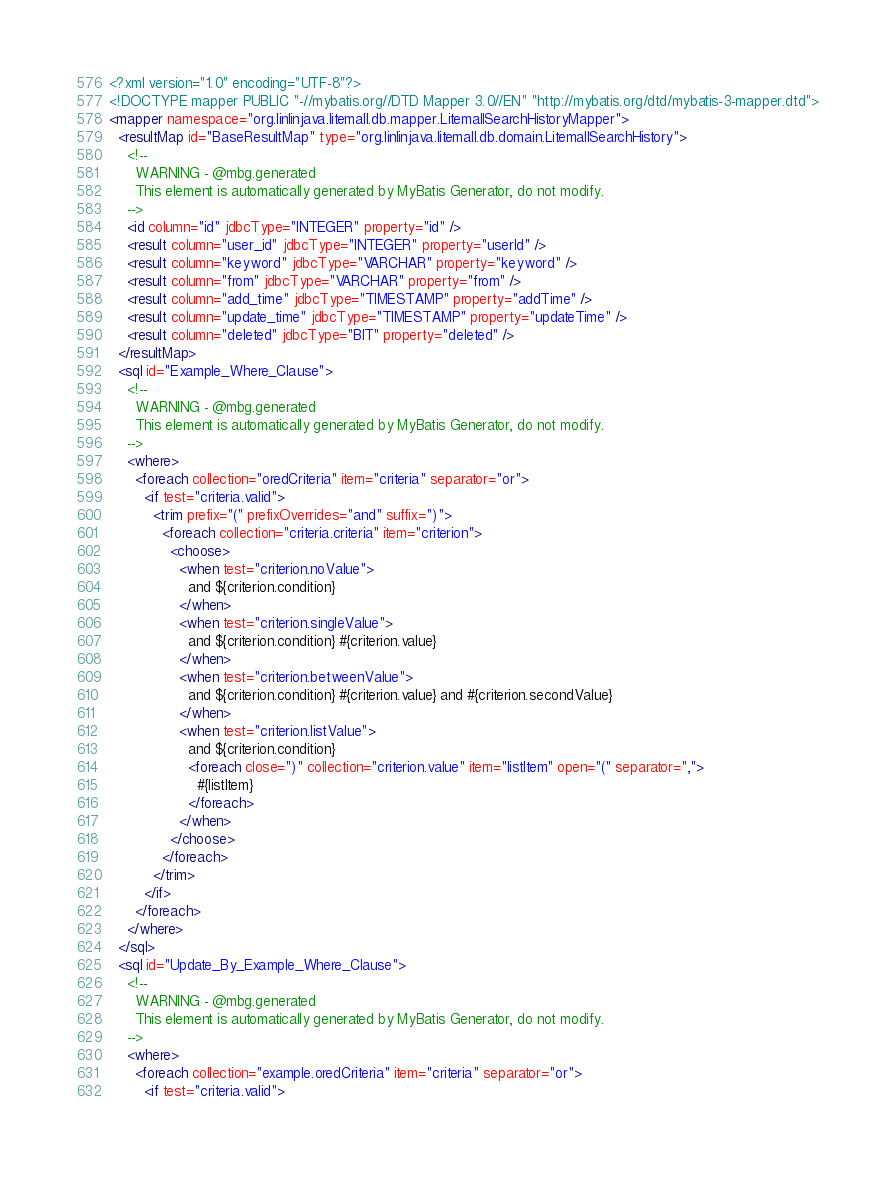Convert code to text. <code><loc_0><loc_0><loc_500><loc_500><_XML_><?xml version="1.0" encoding="UTF-8"?>
<!DOCTYPE mapper PUBLIC "-//mybatis.org//DTD Mapper 3.0//EN" "http://mybatis.org/dtd/mybatis-3-mapper.dtd">
<mapper namespace="org.linlinjava.litemall.db.mapper.LitemallSearchHistoryMapper">
  <resultMap id="BaseResultMap" type="org.linlinjava.litemall.db.domain.LitemallSearchHistory">
    <!--
      WARNING - @mbg.generated
      This element is automatically generated by MyBatis Generator, do not modify.
    -->
    <id column="id" jdbcType="INTEGER" property="id" />
    <result column="user_id" jdbcType="INTEGER" property="userId" />
    <result column="keyword" jdbcType="VARCHAR" property="keyword" />
    <result column="from" jdbcType="VARCHAR" property="from" />
    <result column="add_time" jdbcType="TIMESTAMP" property="addTime" />
    <result column="update_time" jdbcType="TIMESTAMP" property="updateTime" />
    <result column="deleted" jdbcType="BIT" property="deleted" />
  </resultMap>
  <sql id="Example_Where_Clause">
    <!--
      WARNING - @mbg.generated
      This element is automatically generated by MyBatis Generator, do not modify.
    -->
    <where>
      <foreach collection="oredCriteria" item="criteria" separator="or">
        <if test="criteria.valid">
          <trim prefix="(" prefixOverrides="and" suffix=")">
            <foreach collection="criteria.criteria" item="criterion">
              <choose>
                <when test="criterion.noValue">
                  and ${criterion.condition}
                </when>
                <when test="criterion.singleValue">
                  and ${criterion.condition} #{criterion.value}
                </when>
                <when test="criterion.betweenValue">
                  and ${criterion.condition} #{criterion.value} and #{criterion.secondValue}
                </when>
                <when test="criterion.listValue">
                  and ${criterion.condition}
                  <foreach close=")" collection="criterion.value" item="listItem" open="(" separator=",">
                    #{listItem}
                  </foreach>
                </when>
              </choose>
            </foreach>
          </trim>
        </if>
      </foreach>
    </where>
  </sql>
  <sql id="Update_By_Example_Where_Clause">
    <!--
      WARNING - @mbg.generated
      This element is automatically generated by MyBatis Generator, do not modify.
    -->
    <where>
      <foreach collection="example.oredCriteria" item="criteria" separator="or">
        <if test="criteria.valid"></code> 